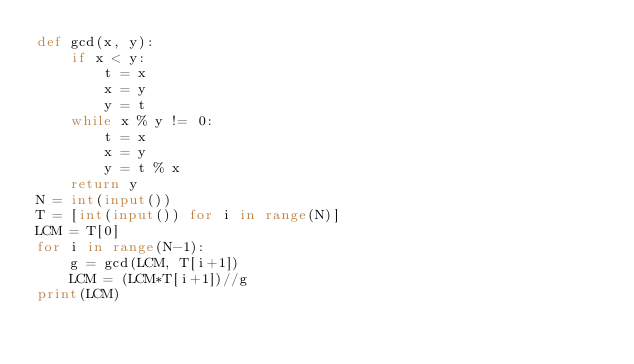<code> <loc_0><loc_0><loc_500><loc_500><_Python_>def gcd(x, y):
    if x < y:
        t = x
        x = y
        y = t
    while x % y != 0:
        t = x
        x = y
        y = t % x
    return y
N = int(input())
T = [int(input()) for i in range(N)]
LCM = T[0]
for i in range(N-1): 
    g = gcd(LCM, T[i+1])
    LCM = (LCM*T[i+1])//g
print(LCM)</code> 